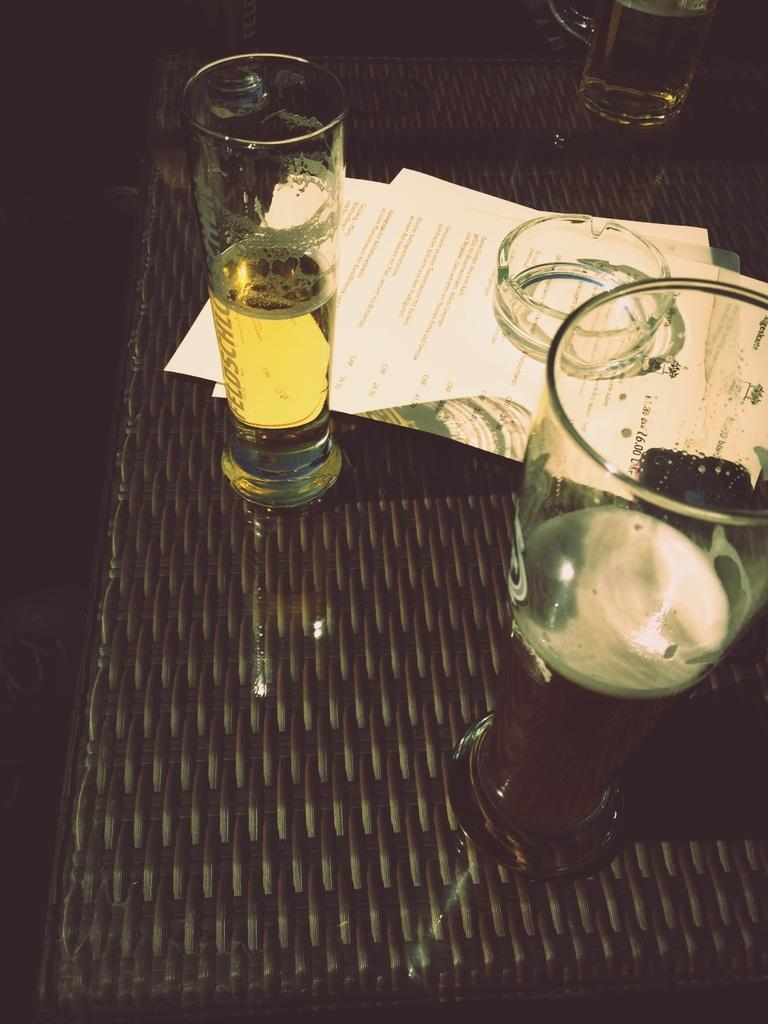What type of furniture is present in the image? There is a table in the image. What items are placed on the table? There are papers and glasses on the table. What is contained within the glasses on the table? There are drinks in the glasses on the table. What type of receipt can be seen on the desk in the image? There is no desk present in the image, and therefore no receipt can be seen. Is there a cannon visible on the table in the image? There is no cannon present on the table in the image. 